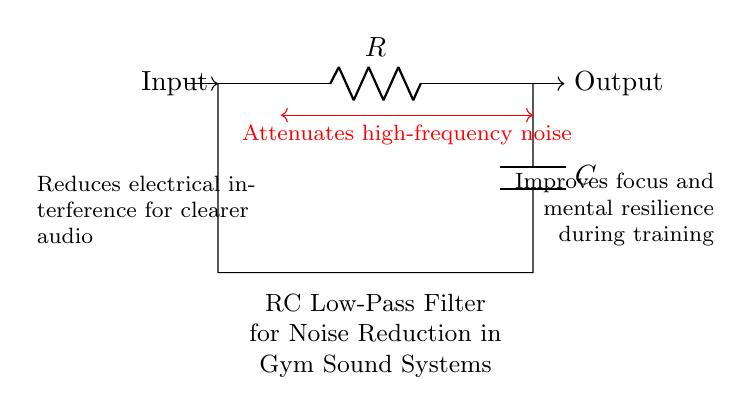What are the components in this circuit? The diagram features a resistor labeled R and a capacitor labeled C. These are the primary components of an RC filter.
Answer: resistor and capacitor What does the arrow labeled "Input" indicate? The arrow indicates where the electrical signal enters the RC filter circuit, allowing it to be processed for noise reduction.
Answer: electrical signal entry What is the purpose of this circuit? The circuit is designed to attenuate high-frequency noise, resulting in clearer audio for gym sound systems to enhance focus.
Answer: noise reduction How does the circuit affect audio quality? The filter reduces electrical interference by allowing low-frequency signals to pass while attenuating high-frequency noise, improving audio clarity.
Answer: improves audio clarity What type of filter is represented in this circuit? This circuit is a low-pass filter, which allows low-frequency signals through while filtering out higher frequencies.
Answer: low-pass filter What kind of training benefits does this circuit provide? The clearer audio passthrough helps to improve focus and mental resilience during training sessions for boxers and athletes.
Answer: improves focus and resilience What is the function of the capacitor in this RC filter? The capacitor stores electrical energy and releases it to smooth out voltage variations, aiding in the reduction of noise from the audio signal.
Answer: smooths voltage variations 